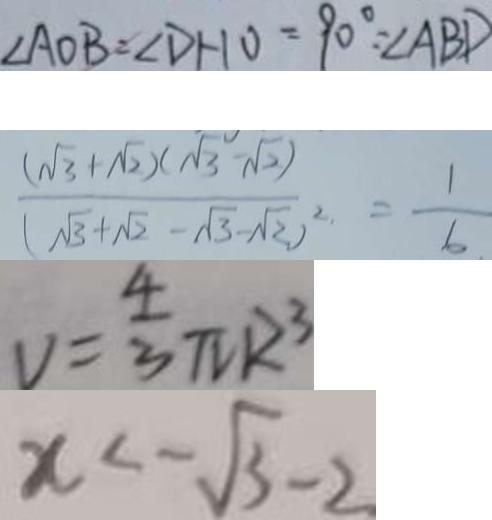Convert formula to latex. <formula><loc_0><loc_0><loc_500><loc_500>\angle A O B = \angle D H O = 9 0 ^ { \circ } = \angle A B D 
 \frac { ( \sqrt { 3 } + \sqrt { 2 } ) ( \sqrt { 3 } - \sqrt { 2 } ) } { ( \sqrt { 3 } + \sqrt { 2 } - \sqrt { 3 } - \sqrt { 2 } ) ^ { 2 } } . = \frac { 1 } { 6 } . 
 v = \frac { 4 } { 3 } \pi R ^ { 3 } 
 x < - \sqrt { 3 } - 2</formula> 